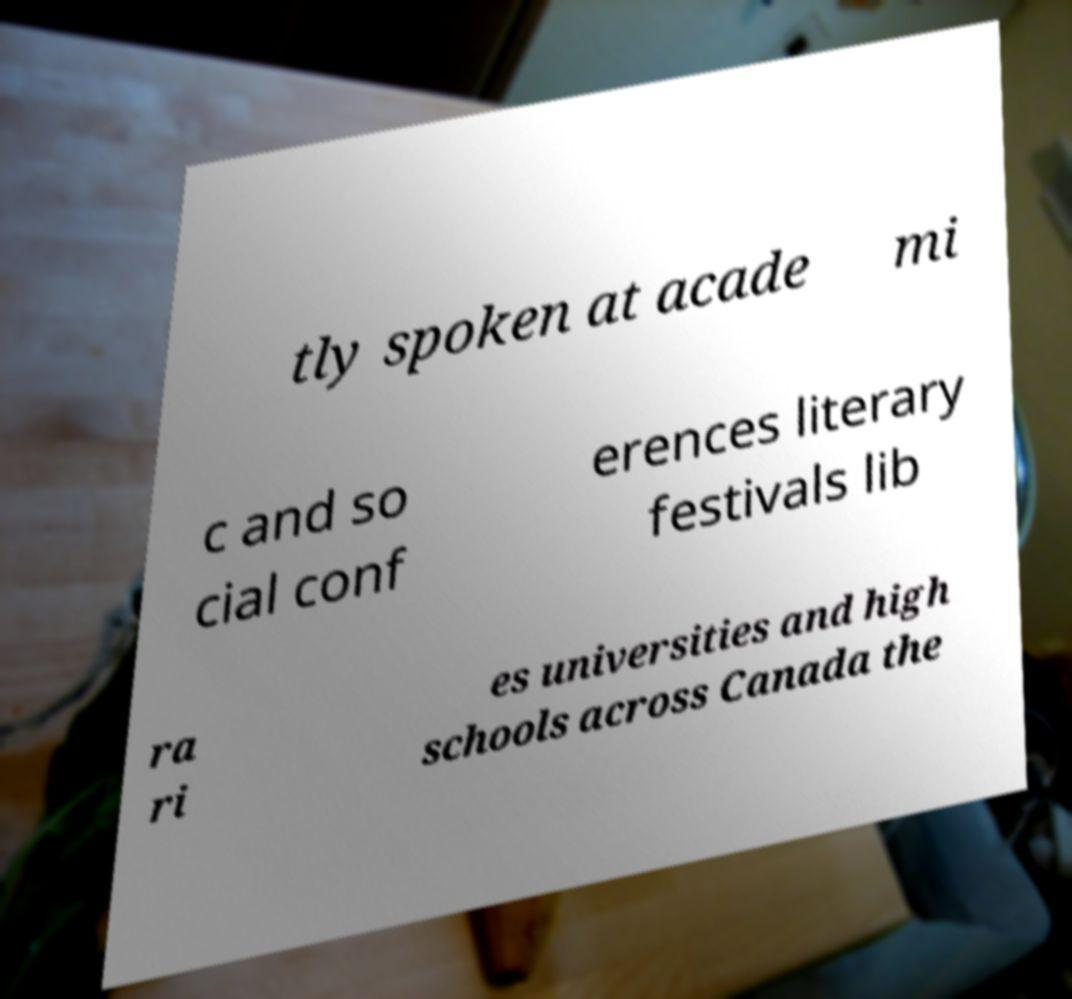Please read and relay the text visible in this image. What does it say? tly spoken at acade mi c and so cial conf erences literary festivals lib ra ri es universities and high schools across Canada the 